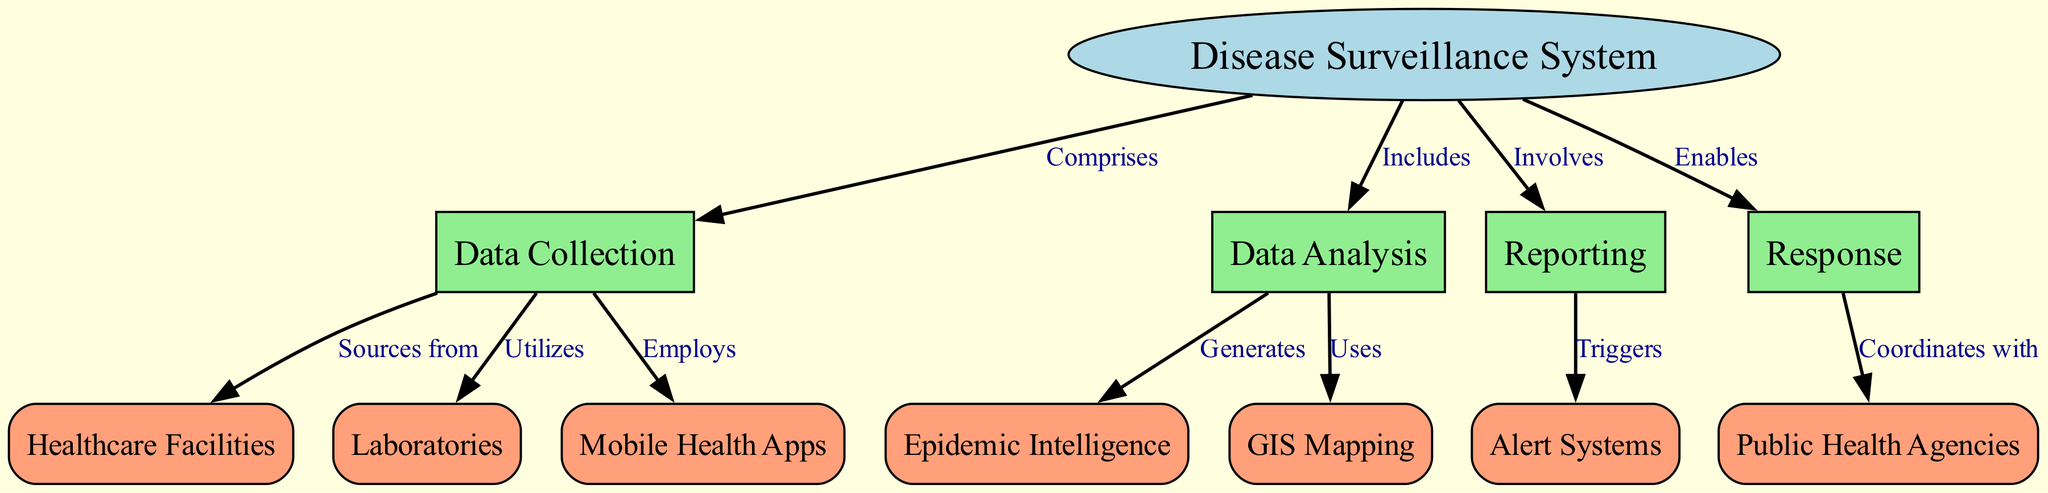What is the main topic of the diagram? The diagram centers around the "Disease Surveillance System," which is represented as the primary node at the top of the structure. This node serves as the foundation for all other components that branch off from it.
Answer: Disease Surveillance System How many key components are directly linked to the Disease Surveillance System? The diagram shows four key components that are directly linked to the central node, which are Data Collection, Data Analysis, Reporting, and Response. Each of these components is represented as a box and is connected to the main node with an edge labeled accordingly.
Answer: Four Which node mentions "Sources from" in its relationship? The relationship labeled "Sources from" connects Data Collection to Healthcare Facilities, indicating that Healthcare Facilities are a source of data used in the surveillance system. This relationship is explicitly noted in the edges of the diagram.
Answer: Healthcare Facilities What is generated as part of Data Analysis? The Data Analysis component generates Epidemic Intelligence, which is indicated by the edge labeled "Generates" that connects these two nodes. This shows that the analysis of gathered data is used to produce important insights related to epidemics.
Answer: Epidemic Intelligence Which two nodes are connected through the term "Utilizes"? The term "Utilizes" connects the Data Collection node to the Laboratories node, indicating that data collection practices make use of laboratory resources or data. This is a direct edge that shows the relationship between these two components in the system.
Answer: Laboratories What action triggers the Alert Systems node? The Alert Systems node is triggered as part of the Reporting component, as shown by the directed edge labeled "Triggers" that connects Reporting to Alert Systems. This relationship illustrates the process by which reporting generates alerts based on the data and findings.
Answer: Reporting Which two components are responsible for coordinating with each other? The Response node coordinates with Public Health Agencies, as indicated by the edge labeled "Coordinates with." This denotes a collaborative relationship between the response efforts in disease surveillance and the public health agencies involved in those responses.
Answer: Public Health Agencies What are the three specific methods employed in Data Collection? Data Collection employs three methods: Healthcare Facilities, Laboratories, and Mobile Health Apps, as indicated by the respective edges that connect to the Data Collection node, showcasing multiple sources and strategies for collecting disease-related data.
Answer: Healthcare Facilities, Laboratories, Mobile Health Apps How many edges are present in the diagram? Upon counting the edges connecting the nodes, there are twelve distinct edges that represent the relationships and functionalities between the various components of the Disease Surveillance System depicted in the diagram.
Answer: Twelve 